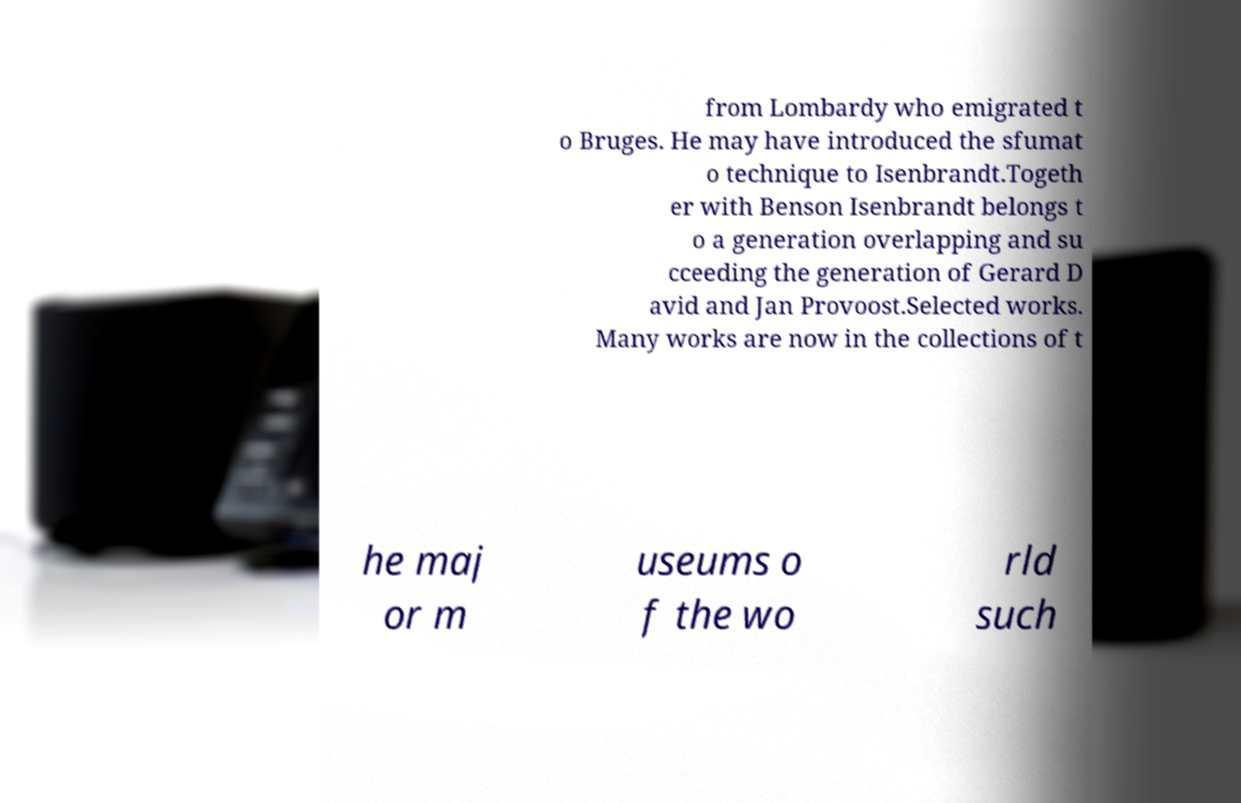Can you read and provide the text displayed in the image?This photo seems to have some interesting text. Can you extract and type it out for me? from Lombardy who emigrated t o Bruges. He may have introduced the sfumat o technique to Isenbrandt.Togeth er with Benson Isenbrandt belongs t o a generation overlapping and su cceeding the generation of Gerard D avid and Jan Provoost.Selected works. Many works are now in the collections of t he maj or m useums o f the wo rld such 